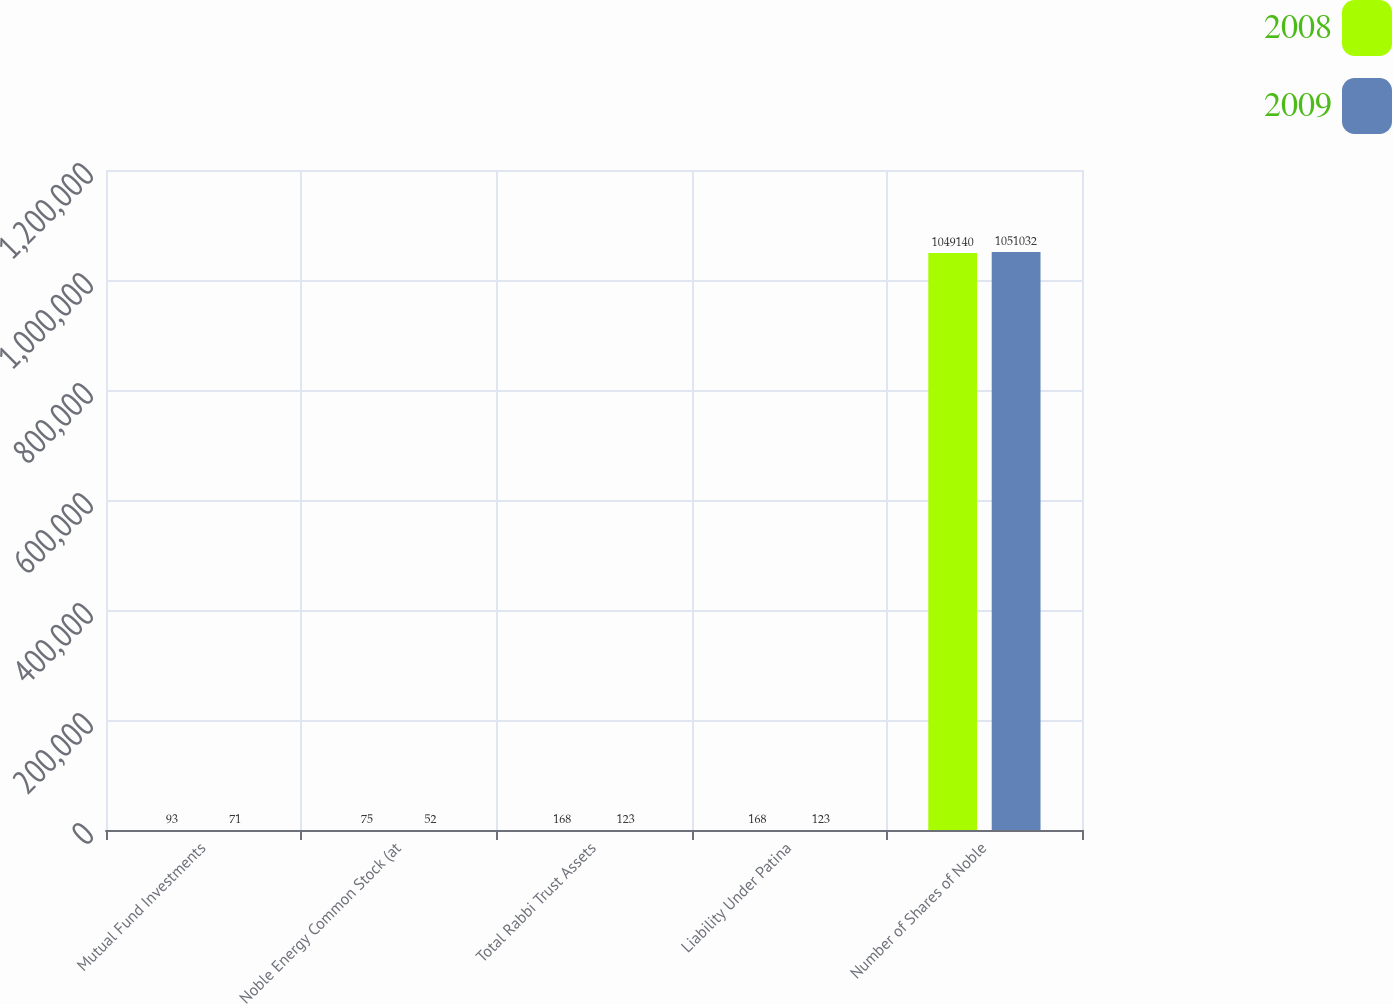<chart> <loc_0><loc_0><loc_500><loc_500><stacked_bar_chart><ecel><fcel>Mutual Fund Investments<fcel>Noble Energy Common Stock (at<fcel>Total Rabbi Trust Assets<fcel>Liability Under Patina<fcel>Number of Shares of Noble<nl><fcel>2008<fcel>93<fcel>75<fcel>168<fcel>168<fcel>1.04914e+06<nl><fcel>2009<fcel>71<fcel>52<fcel>123<fcel>123<fcel>1.05103e+06<nl></chart> 